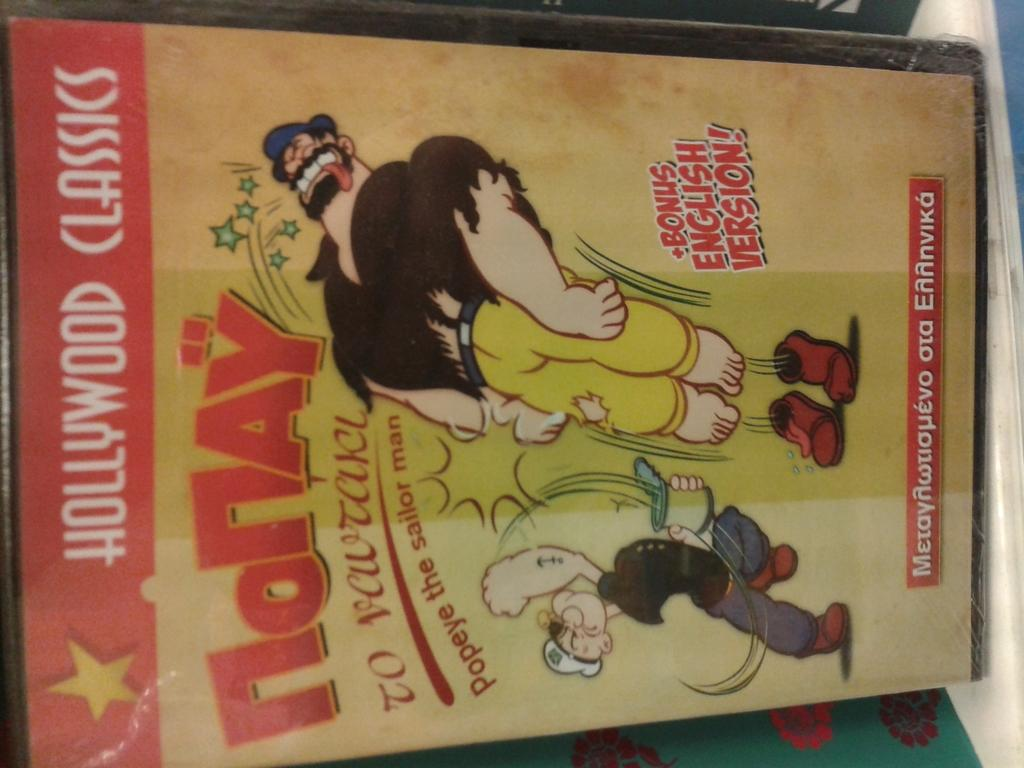<image>
Create a compact narrative representing the image presented. The comic book here is about Popeye The Sailor 